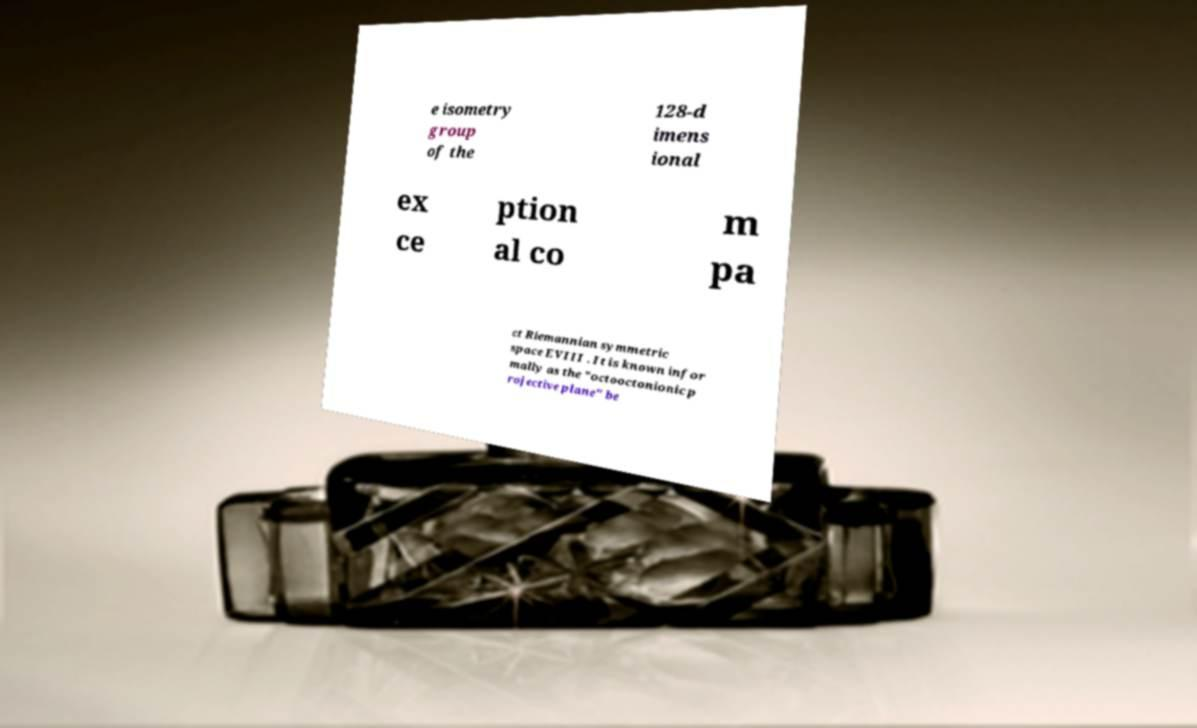Can you read and provide the text displayed in the image?This photo seems to have some interesting text. Can you extract and type it out for me? e isometry group of the 128-d imens ional ex ce ption al co m pa ct Riemannian symmetric space EVIII . It is known infor mally as the "octooctonionic p rojective plane" be 